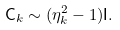Convert formula to latex. <formula><loc_0><loc_0><loc_500><loc_500>\mathsf C _ { k } \sim ( \eta _ { k } ^ { 2 } - 1 ) \mathsf I .</formula> 